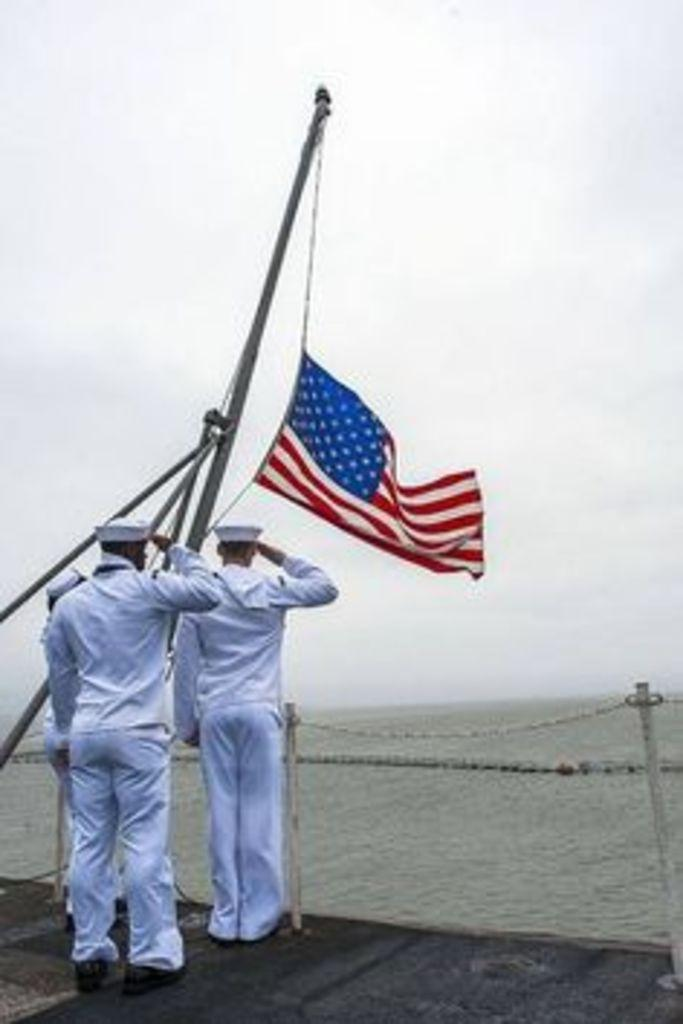What are the people in the image doing? The people in the image are standing on the ground and saluting. What object is associated with the flag in the image? There is a flag with a rod in the image. What natural elements can be seen in the image? Water and sky are visible in the image. What additional objects can be seen in the image? There are sticks with ropes in the image. What type of ball is being used by the horse in the image? There is no horse or ball present in the image. 